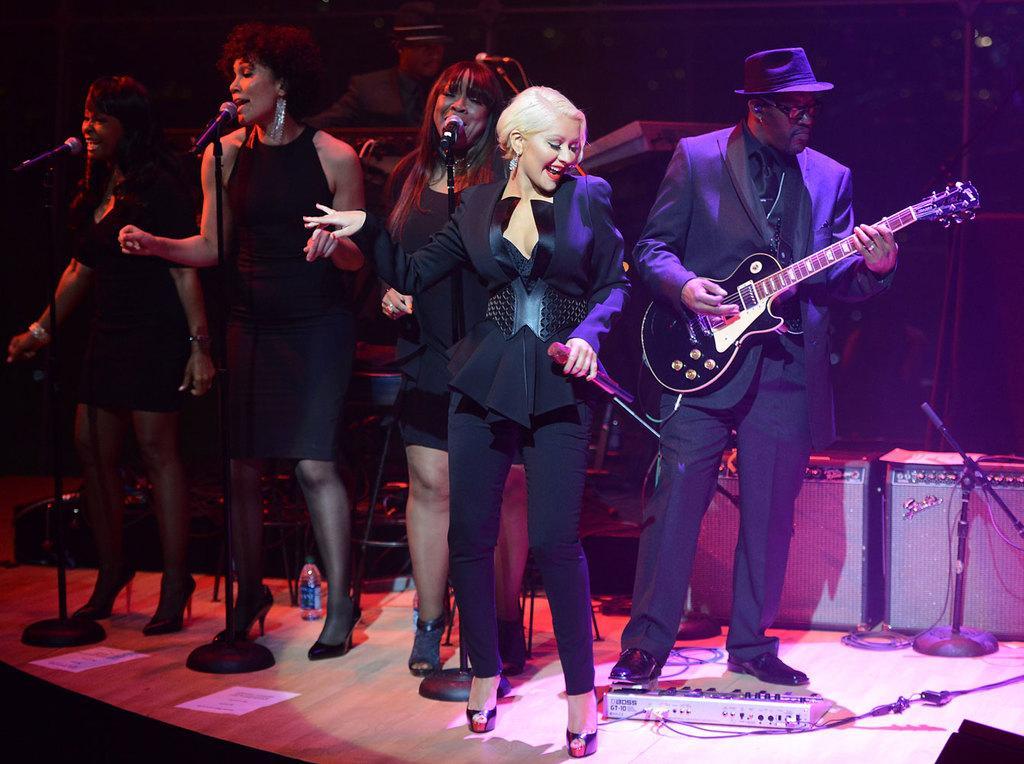How would you summarize this image in a sentence or two? In the image we can see there are people who are standing on stage and a man is holding guitar in his hand and a woman is holding mic in her hand. 